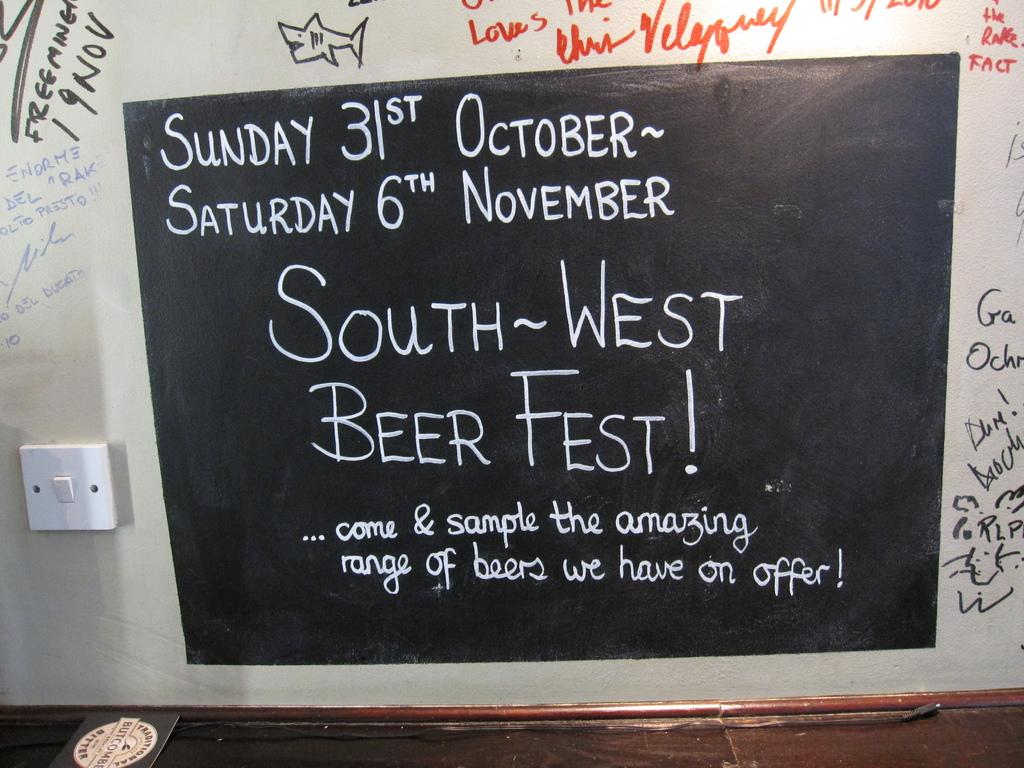<image>
Write a terse but informative summary of the picture. A chalkboard sign that says from Sunday October 31 to Saturday November 6 there will be a South-West Beer Fest. 